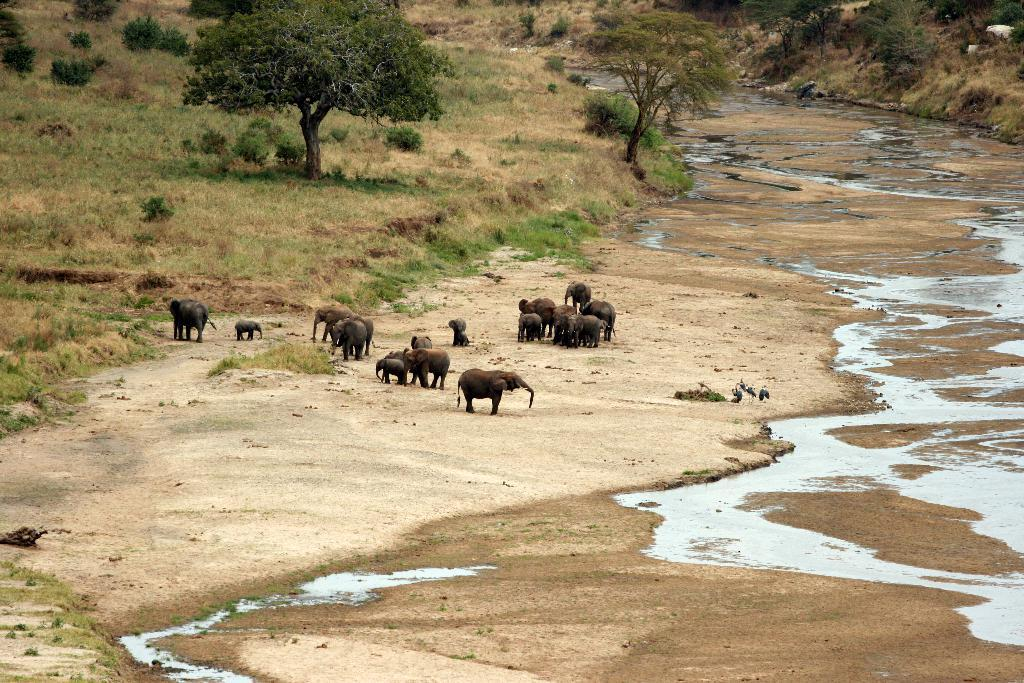What is visible at the bottom of the image? Soil, grass, and water are visible at the bottom of the image. What animals can be seen in the image? Elephants and calves are present in the image. Are there any other living creatures in the image? Yes, there are birds in the image. What can be seen in the background of the image? Trees and grass are visible in the background of the image. What type of curve can be seen in the water in the image? There is no curve visible in the water in the image. How many visitors are present in the image? There is no mention of visitors in the image; it features elephants, calves, and birds. 